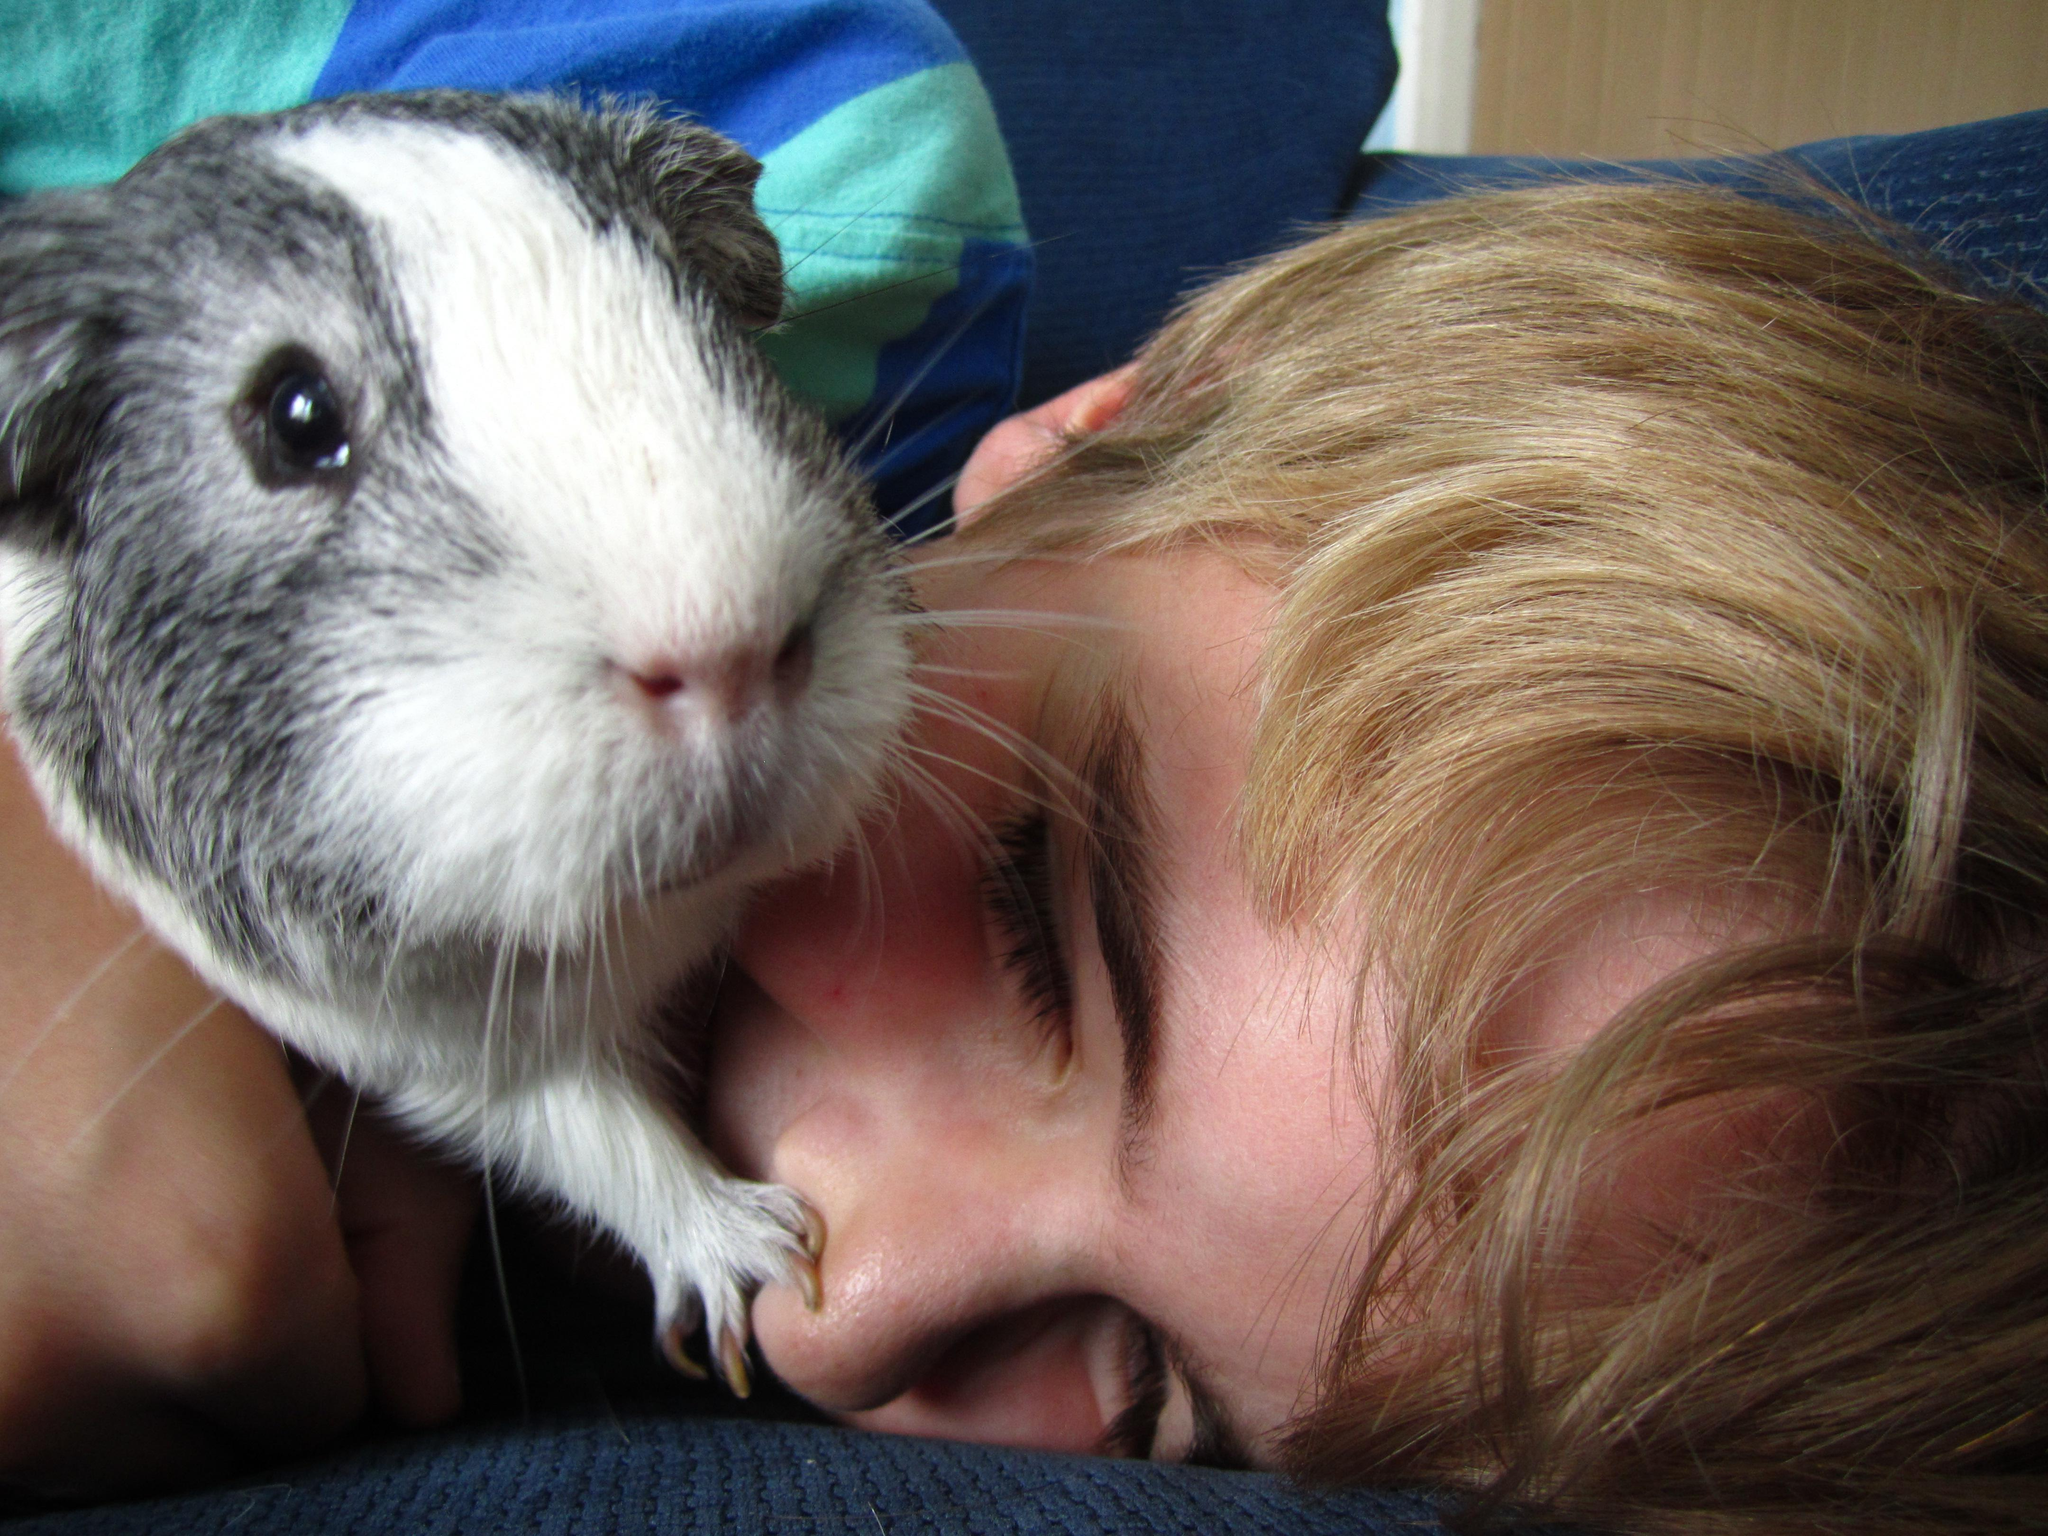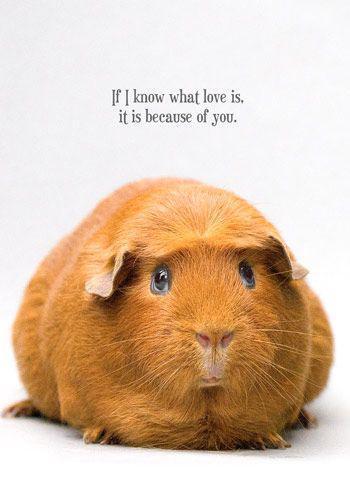The first image is the image on the left, the second image is the image on the right. Assess this claim about the two images: "Each image shows two side-by-side guinea pigs.". Correct or not? Answer yes or no. No. The first image is the image on the left, the second image is the image on the right. Given the left and right images, does the statement "The right image contains exactly one rodent." hold true? Answer yes or no. Yes. 